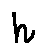<formula> <loc_0><loc_0><loc_500><loc_500>h</formula> 